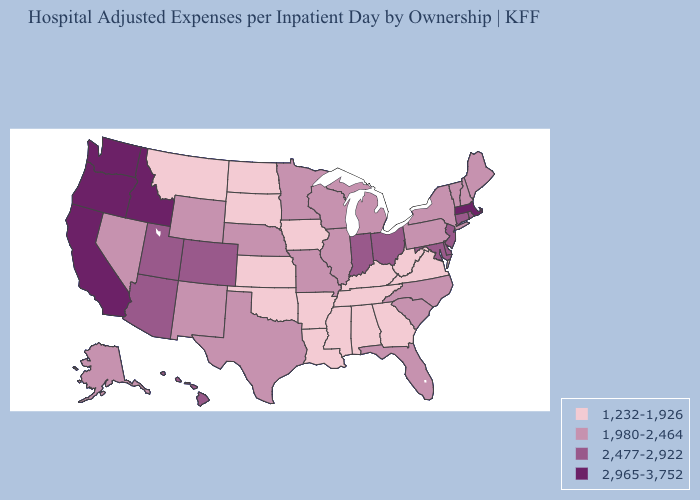Does Washington have the lowest value in the USA?
Give a very brief answer. No. How many symbols are there in the legend?
Short answer required. 4. What is the highest value in the West ?
Be succinct. 2,965-3,752. Name the states that have a value in the range 2,477-2,922?
Quick response, please. Arizona, Colorado, Connecticut, Delaware, Hawaii, Indiana, Maryland, New Jersey, Ohio, Rhode Island, Utah. Does South Carolina have the lowest value in the USA?
Be succinct. No. Does Kentucky have the same value as Arkansas?
Short answer required. Yes. Is the legend a continuous bar?
Short answer required. No. What is the lowest value in states that border Pennsylvania?
Write a very short answer. 1,232-1,926. What is the highest value in the West ?
Answer briefly. 2,965-3,752. Name the states that have a value in the range 2,477-2,922?
Keep it brief. Arizona, Colorado, Connecticut, Delaware, Hawaii, Indiana, Maryland, New Jersey, Ohio, Rhode Island, Utah. Name the states that have a value in the range 2,965-3,752?
Be succinct. California, Idaho, Massachusetts, Oregon, Washington. Among the states that border Illinois , does Missouri have the highest value?
Give a very brief answer. No. What is the value of Massachusetts?
Be succinct. 2,965-3,752. Name the states that have a value in the range 2,965-3,752?
Give a very brief answer. California, Idaho, Massachusetts, Oregon, Washington. Which states have the lowest value in the West?
Keep it brief. Montana. 